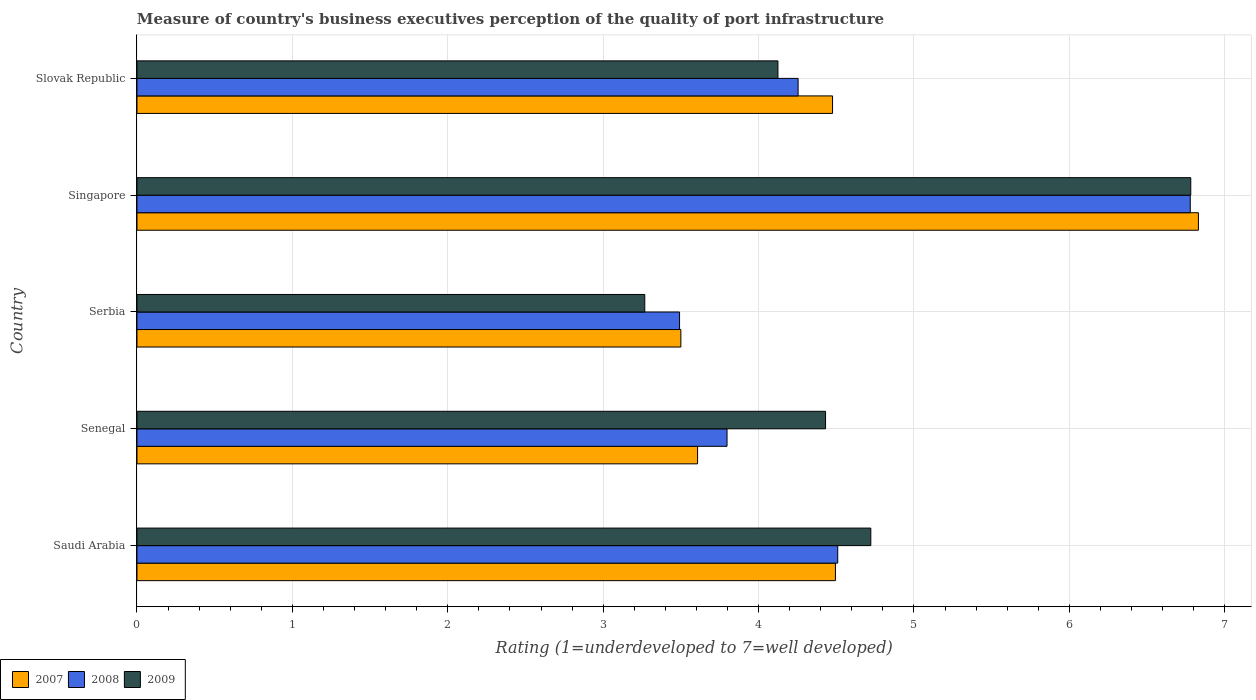How many different coloured bars are there?
Your response must be concise. 3. How many groups of bars are there?
Give a very brief answer. 5. How many bars are there on the 5th tick from the top?
Provide a succinct answer. 3. How many bars are there on the 3rd tick from the bottom?
Your answer should be compact. 3. What is the label of the 3rd group of bars from the top?
Offer a terse response. Serbia. What is the ratings of the quality of port infrastructure in 2007 in Slovak Republic?
Provide a short and direct response. 4.48. Across all countries, what is the maximum ratings of the quality of port infrastructure in 2007?
Your answer should be very brief. 6.83. Across all countries, what is the minimum ratings of the quality of port infrastructure in 2007?
Make the answer very short. 3.5. In which country was the ratings of the quality of port infrastructure in 2009 maximum?
Your response must be concise. Singapore. In which country was the ratings of the quality of port infrastructure in 2008 minimum?
Your response must be concise. Serbia. What is the total ratings of the quality of port infrastructure in 2008 in the graph?
Offer a very short reply. 22.83. What is the difference between the ratings of the quality of port infrastructure in 2007 in Senegal and that in Serbia?
Keep it short and to the point. 0.11. What is the difference between the ratings of the quality of port infrastructure in 2008 in Saudi Arabia and the ratings of the quality of port infrastructure in 2009 in Singapore?
Make the answer very short. -2.27. What is the average ratings of the quality of port infrastructure in 2007 per country?
Offer a terse response. 4.58. What is the difference between the ratings of the quality of port infrastructure in 2009 and ratings of the quality of port infrastructure in 2007 in Slovak Republic?
Provide a succinct answer. -0.35. What is the ratio of the ratings of the quality of port infrastructure in 2008 in Saudi Arabia to that in Serbia?
Provide a short and direct response. 1.29. Is the ratings of the quality of port infrastructure in 2009 in Serbia less than that in Slovak Republic?
Offer a very short reply. Yes. What is the difference between the highest and the second highest ratings of the quality of port infrastructure in 2007?
Your answer should be compact. 2.34. What is the difference between the highest and the lowest ratings of the quality of port infrastructure in 2007?
Make the answer very short. 3.33. In how many countries, is the ratings of the quality of port infrastructure in 2007 greater than the average ratings of the quality of port infrastructure in 2007 taken over all countries?
Keep it short and to the point. 1. Is the sum of the ratings of the quality of port infrastructure in 2007 in Senegal and Singapore greater than the maximum ratings of the quality of port infrastructure in 2008 across all countries?
Your answer should be very brief. Yes. What does the 1st bar from the top in Saudi Arabia represents?
Provide a short and direct response. 2009. How many bars are there?
Make the answer very short. 15. Are all the bars in the graph horizontal?
Provide a short and direct response. Yes. What is the difference between two consecutive major ticks on the X-axis?
Give a very brief answer. 1. Are the values on the major ticks of X-axis written in scientific E-notation?
Give a very brief answer. No. Does the graph contain grids?
Your answer should be very brief. Yes. Where does the legend appear in the graph?
Offer a terse response. Bottom left. How many legend labels are there?
Give a very brief answer. 3. How are the legend labels stacked?
Keep it short and to the point. Horizontal. What is the title of the graph?
Ensure brevity in your answer.  Measure of country's business executives perception of the quality of port infrastructure. Does "1981" appear as one of the legend labels in the graph?
Your response must be concise. No. What is the label or title of the X-axis?
Your answer should be very brief. Rating (1=underdeveloped to 7=well developed). What is the label or title of the Y-axis?
Your response must be concise. Country. What is the Rating (1=underdeveloped to 7=well developed) of 2007 in Saudi Arabia?
Keep it short and to the point. 4.49. What is the Rating (1=underdeveloped to 7=well developed) in 2008 in Saudi Arabia?
Provide a succinct answer. 4.51. What is the Rating (1=underdeveloped to 7=well developed) in 2009 in Saudi Arabia?
Provide a succinct answer. 4.72. What is the Rating (1=underdeveloped to 7=well developed) in 2007 in Senegal?
Offer a very short reply. 3.61. What is the Rating (1=underdeveloped to 7=well developed) of 2008 in Senegal?
Provide a succinct answer. 3.8. What is the Rating (1=underdeveloped to 7=well developed) in 2009 in Senegal?
Your answer should be compact. 4.43. What is the Rating (1=underdeveloped to 7=well developed) in 2007 in Serbia?
Keep it short and to the point. 3.5. What is the Rating (1=underdeveloped to 7=well developed) of 2008 in Serbia?
Offer a very short reply. 3.49. What is the Rating (1=underdeveloped to 7=well developed) of 2009 in Serbia?
Keep it short and to the point. 3.27. What is the Rating (1=underdeveloped to 7=well developed) in 2007 in Singapore?
Ensure brevity in your answer.  6.83. What is the Rating (1=underdeveloped to 7=well developed) in 2008 in Singapore?
Your response must be concise. 6.78. What is the Rating (1=underdeveloped to 7=well developed) in 2009 in Singapore?
Your answer should be compact. 6.78. What is the Rating (1=underdeveloped to 7=well developed) in 2007 in Slovak Republic?
Offer a very short reply. 4.48. What is the Rating (1=underdeveloped to 7=well developed) of 2008 in Slovak Republic?
Ensure brevity in your answer.  4.25. What is the Rating (1=underdeveloped to 7=well developed) in 2009 in Slovak Republic?
Keep it short and to the point. 4.12. Across all countries, what is the maximum Rating (1=underdeveloped to 7=well developed) of 2007?
Your response must be concise. 6.83. Across all countries, what is the maximum Rating (1=underdeveloped to 7=well developed) in 2008?
Your answer should be compact. 6.78. Across all countries, what is the maximum Rating (1=underdeveloped to 7=well developed) in 2009?
Provide a succinct answer. 6.78. Across all countries, what is the minimum Rating (1=underdeveloped to 7=well developed) of 2008?
Provide a succinct answer. 3.49. Across all countries, what is the minimum Rating (1=underdeveloped to 7=well developed) in 2009?
Provide a short and direct response. 3.27. What is the total Rating (1=underdeveloped to 7=well developed) in 2007 in the graph?
Make the answer very short. 22.91. What is the total Rating (1=underdeveloped to 7=well developed) in 2008 in the graph?
Your response must be concise. 22.83. What is the total Rating (1=underdeveloped to 7=well developed) in 2009 in the graph?
Keep it short and to the point. 23.33. What is the difference between the Rating (1=underdeveloped to 7=well developed) in 2007 in Saudi Arabia and that in Senegal?
Keep it short and to the point. 0.89. What is the difference between the Rating (1=underdeveloped to 7=well developed) in 2008 in Saudi Arabia and that in Senegal?
Make the answer very short. 0.71. What is the difference between the Rating (1=underdeveloped to 7=well developed) in 2009 in Saudi Arabia and that in Senegal?
Offer a very short reply. 0.29. What is the difference between the Rating (1=underdeveloped to 7=well developed) of 2008 in Saudi Arabia and that in Serbia?
Your answer should be compact. 1.02. What is the difference between the Rating (1=underdeveloped to 7=well developed) of 2009 in Saudi Arabia and that in Serbia?
Your response must be concise. 1.45. What is the difference between the Rating (1=underdeveloped to 7=well developed) in 2007 in Saudi Arabia and that in Singapore?
Offer a very short reply. -2.34. What is the difference between the Rating (1=underdeveloped to 7=well developed) of 2008 in Saudi Arabia and that in Singapore?
Give a very brief answer. -2.27. What is the difference between the Rating (1=underdeveloped to 7=well developed) of 2009 in Saudi Arabia and that in Singapore?
Provide a short and direct response. -2.06. What is the difference between the Rating (1=underdeveloped to 7=well developed) in 2007 in Saudi Arabia and that in Slovak Republic?
Provide a succinct answer. 0.02. What is the difference between the Rating (1=underdeveloped to 7=well developed) in 2008 in Saudi Arabia and that in Slovak Republic?
Offer a very short reply. 0.25. What is the difference between the Rating (1=underdeveloped to 7=well developed) in 2009 in Saudi Arabia and that in Slovak Republic?
Offer a very short reply. 0.6. What is the difference between the Rating (1=underdeveloped to 7=well developed) of 2007 in Senegal and that in Serbia?
Keep it short and to the point. 0.11. What is the difference between the Rating (1=underdeveloped to 7=well developed) in 2008 in Senegal and that in Serbia?
Keep it short and to the point. 0.31. What is the difference between the Rating (1=underdeveloped to 7=well developed) in 2009 in Senegal and that in Serbia?
Keep it short and to the point. 1.16. What is the difference between the Rating (1=underdeveloped to 7=well developed) of 2007 in Senegal and that in Singapore?
Your answer should be compact. -3.22. What is the difference between the Rating (1=underdeveloped to 7=well developed) of 2008 in Senegal and that in Singapore?
Ensure brevity in your answer.  -2.98. What is the difference between the Rating (1=underdeveloped to 7=well developed) of 2009 in Senegal and that in Singapore?
Provide a succinct answer. -2.35. What is the difference between the Rating (1=underdeveloped to 7=well developed) in 2007 in Senegal and that in Slovak Republic?
Provide a short and direct response. -0.87. What is the difference between the Rating (1=underdeveloped to 7=well developed) of 2008 in Senegal and that in Slovak Republic?
Your response must be concise. -0.46. What is the difference between the Rating (1=underdeveloped to 7=well developed) of 2009 in Senegal and that in Slovak Republic?
Your answer should be very brief. 0.31. What is the difference between the Rating (1=underdeveloped to 7=well developed) in 2007 in Serbia and that in Singapore?
Give a very brief answer. -3.33. What is the difference between the Rating (1=underdeveloped to 7=well developed) in 2008 in Serbia and that in Singapore?
Give a very brief answer. -3.29. What is the difference between the Rating (1=underdeveloped to 7=well developed) of 2009 in Serbia and that in Singapore?
Make the answer very short. -3.51. What is the difference between the Rating (1=underdeveloped to 7=well developed) in 2007 in Serbia and that in Slovak Republic?
Make the answer very short. -0.98. What is the difference between the Rating (1=underdeveloped to 7=well developed) of 2008 in Serbia and that in Slovak Republic?
Your answer should be compact. -0.76. What is the difference between the Rating (1=underdeveloped to 7=well developed) of 2009 in Serbia and that in Slovak Republic?
Provide a succinct answer. -0.86. What is the difference between the Rating (1=underdeveloped to 7=well developed) in 2007 in Singapore and that in Slovak Republic?
Your response must be concise. 2.35. What is the difference between the Rating (1=underdeveloped to 7=well developed) in 2008 in Singapore and that in Slovak Republic?
Keep it short and to the point. 2.52. What is the difference between the Rating (1=underdeveloped to 7=well developed) of 2009 in Singapore and that in Slovak Republic?
Give a very brief answer. 2.66. What is the difference between the Rating (1=underdeveloped to 7=well developed) of 2007 in Saudi Arabia and the Rating (1=underdeveloped to 7=well developed) of 2008 in Senegal?
Make the answer very short. 0.7. What is the difference between the Rating (1=underdeveloped to 7=well developed) in 2007 in Saudi Arabia and the Rating (1=underdeveloped to 7=well developed) in 2009 in Senegal?
Your answer should be compact. 0.06. What is the difference between the Rating (1=underdeveloped to 7=well developed) in 2008 in Saudi Arabia and the Rating (1=underdeveloped to 7=well developed) in 2009 in Senegal?
Offer a very short reply. 0.08. What is the difference between the Rating (1=underdeveloped to 7=well developed) of 2007 in Saudi Arabia and the Rating (1=underdeveloped to 7=well developed) of 2008 in Serbia?
Provide a short and direct response. 1. What is the difference between the Rating (1=underdeveloped to 7=well developed) of 2007 in Saudi Arabia and the Rating (1=underdeveloped to 7=well developed) of 2009 in Serbia?
Offer a very short reply. 1.23. What is the difference between the Rating (1=underdeveloped to 7=well developed) in 2008 in Saudi Arabia and the Rating (1=underdeveloped to 7=well developed) in 2009 in Serbia?
Your answer should be compact. 1.24. What is the difference between the Rating (1=underdeveloped to 7=well developed) in 2007 in Saudi Arabia and the Rating (1=underdeveloped to 7=well developed) in 2008 in Singapore?
Your answer should be very brief. -2.28. What is the difference between the Rating (1=underdeveloped to 7=well developed) of 2007 in Saudi Arabia and the Rating (1=underdeveloped to 7=well developed) of 2009 in Singapore?
Ensure brevity in your answer.  -2.29. What is the difference between the Rating (1=underdeveloped to 7=well developed) of 2008 in Saudi Arabia and the Rating (1=underdeveloped to 7=well developed) of 2009 in Singapore?
Give a very brief answer. -2.27. What is the difference between the Rating (1=underdeveloped to 7=well developed) in 2007 in Saudi Arabia and the Rating (1=underdeveloped to 7=well developed) in 2008 in Slovak Republic?
Provide a short and direct response. 0.24. What is the difference between the Rating (1=underdeveloped to 7=well developed) of 2007 in Saudi Arabia and the Rating (1=underdeveloped to 7=well developed) of 2009 in Slovak Republic?
Offer a terse response. 0.37. What is the difference between the Rating (1=underdeveloped to 7=well developed) of 2008 in Saudi Arabia and the Rating (1=underdeveloped to 7=well developed) of 2009 in Slovak Republic?
Provide a short and direct response. 0.38. What is the difference between the Rating (1=underdeveloped to 7=well developed) of 2007 in Senegal and the Rating (1=underdeveloped to 7=well developed) of 2008 in Serbia?
Your answer should be very brief. 0.12. What is the difference between the Rating (1=underdeveloped to 7=well developed) in 2007 in Senegal and the Rating (1=underdeveloped to 7=well developed) in 2009 in Serbia?
Your answer should be compact. 0.34. What is the difference between the Rating (1=underdeveloped to 7=well developed) in 2008 in Senegal and the Rating (1=underdeveloped to 7=well developed) in 2009 in Serbia?
Offer a terse response. 0.53. What is the difference between the Rating (1=underdeveloped to 7=well developed) in 2007 in Senegal and the Rating (1=underdeveloped to 7=well developed) in 2008 in Singapore?
Make the answer very short. -3.17. What is the difference between the Rating (1=underdeveloped to 7=well developed) of 2007 in Senegal and the Rating (1=underdeveloped to 7=well developed) of 2009 in Singapore?
Your answer should be compact. -3.17. What is the difference between the Rating (1=underdeveloped to 7=well developed) in 2008 in Senegal and the Rating (1=underdeveloped to 7=well developed) in 2009 in Singapore?
Ensure brevity in your answer.  -2.98. What is the difference between the Rating (1=underdeveloped to 7=well developed) in 2007 in Senegal and the Rating (1=underdeveloped to 7=well developed) in 2008 in Slovak Republic?
Offer a terse response. -0.65. What is the difference between the Rating (1=underdeveloped to 7=well developed) in 2007 in Senegal and the Rating (1=underdeveloped to 7=well developed) in 2009 in Slovak Republic?
Ensure brevity in your answer.  -0.52. What is the difference between the Rating (1=underdeveloped to 7=well developed) in 2008 in Senegal and the Rating (1=underdeveloped to 7=well developed) in 2009 in Slovak Republic?
Provide a succinct answer. -0.33. What is the difference between the Rating (1=underdeveloped to 7=well developed) of 2007 in Serbia and the Rating (1=underdeveloped to 7=well developed) of 2008 in Singapore?
Give a very brief answer. -3.28. What is the difference between the Rating (1=underdeveloped to 7=well developed) in 2007 in Serbia and the Rating (1=underdeveloped to 7=well developed) in 2009 in Singapore?
Your answer should be very brief. -3.28. What is the difference between the Rating (1=underdeveloped to 7=well developed) of 2008 in Serbia and the Rating (1=underdeveloped to 7=well developed) of 2009 in Singapore?
Give a very brief answer. -3.29. What is the difference between the Rating (1=underdeveloped to 7=well developed) in 2007 in Serbia and the Rating (1=underdeveloped to 7=well developed) in 2008 in Slovak Republic?
Keep it short and to the point. -0.75. What is the difference between the Rating (1=underdeveloped to 7=well developed) in 2007 in Serbia and the Rating (1=underdeveloped to 7=well developed) in 2009 in Slovak Republic?
Your response must be concise. -0.62. What is the difference between the Rating (1=underdeveloped to 7=well developed) in 2008 in Serbia and the Rating (1=underdeveloped to 7=well developed) in 2009 in Slovak Republic?
Make the answer very short. -0.63. What is the difference between the Rating (1=underdeveloped to 7=well developed) in 2007 in Singapore and the Rating (1=underdeveloped to 7=well developed) in 2008 in Slovak Republic?
Offer a very short reply. 2.58. What is the difference between the Rating (1=underdeveloped to 7=well developed) of 2007 in Singapore and the Rating (1=underdeveloped to 7=well developed) of 2009 in Slovak Republic?
Your response must be concise. 2.71. What is the difference between the Rating (1=underdeveloped to 7=well developed) in 2008 in Singapore and the Rating (1=underdeveloped to 7=well developed) in 2009 in Slovak Republic?
Offer a very short reply. 2.65. What is the average Rating (1=underdeveloped to 7=well developed) in 2007 per country?
Your answer should be very brief. 4.58. What is the average Rating (1=underdeveloped to 7=well developed) of 2008 per country?
Offer a terse response. 4.57. What is the average Rating (1=underdeveloped to 7=well developed) of 2009 per country?
Ensure brevity in your answer.  4.67. What is the difference between the Rating (1=underdeveloped to 7=well developed) of 2007 and Rating (1=underdeveloped to 7=well developed) of 2008 in Saudi Arabia?
Offer a terse response. -0.01. What is the difference between the Rating (1=underdeveloped to 7=well developed) of 2007 and Rating (1=underdeveloped to 7=well developed) of 2009 in Saudi Arabia?
Offer a terse response. -0.23. What is the difference between the Rating (1=underdeveloped to 7=well developed) in 2008 and Rating (1=underdeveloped to 7=well developed) in 2009 in Saudi Arabia?
Give a very brief answer. -0.21. What is the difference between the Rating (1=underdeveloped to 7=well developed) in 2007 and Rating (1=underdeveloped to 7=well developed) in 2008 in Senegal?
Provide a succinct answer. -0.19. What is the difference between the Rating (1=underdeveloped to 7=well developed) in 2007 and Rating (1=underdeveloped to 7=well developed) in 2009 in Senegal?
Keep it short and to the point. -0.82. What is the difference between the Rating (1=underdeveloped to 7=well developed) in 2008 and Rating (1=underdeveloped to 7=well developed) in 2009 in Senegal?
Make the answer very short. -0.63. What is the difference between the Rating (1=underdeveloped to 7=well developed) in 2007 and Rating (1=underdeveloped to 7=well developed) in 2008 in Serbia?
Keep it short and to the point. 0.01. What is the difference between the Rating (1=underdeveloped to 7=well developed) of 2007 and Rating (1=underdeveloped to 7=well developed) of 2009 in Serbia?
Keep it short and to the point. 0.23. What is the difference between the Rating (1=underdeveloped to 7=well developed) of 2008 and Rating (1=underdeveloped to 7=well developed) of 2009 in Serbia?
Offer a terse response. 0.22. What is the difference between the Rating (1=underdeveloped to 7=well developed) of 2007 and Rating (1=underdeveloped to 7=well developed) of 2008 in Singapore?
Keep it short and to the point. 0.05. What is the difference between the Rating (1=underdeveloped to 7=well developed) of 2007 and Rating (1=underdeveloped to 7=well developed) of 2009 in Singapore?
Your answer should be compact. 0.05. What is the difference between the Rating (1=underdeveloped to 7=well developed) in 2008 and Rating (1=underdeveloped to 7=well developed) in 2009 in Singapore?
Give a very brief answer. -0. What is the difference between the Rating (1=underdeveloped to 7=well developed) of 2007 and Rating (1=underdeveloped to 7=well developed) of 2008 in Slovak Republic?
Give a very brief answer. 0.22. What is the difference between the Rating (1=underdeveloped to 7=well developed) in 2007 and Rating (1=underdeveloped to 7=well developed) in 2009 in Slovak Republic?
Offer a very short reply. 0.35. What is the difference between the Rating (1=underdeveloped to 7=well developed) of 2008 and Rating (1=underdeveloped to 7=well developed) of 2009 in Slovak Republic?
Your answer should be very brief. 0.13. What is the ratio of the Rating (1=underdeveloped to 7=well developed) in 2007 in Saudi Arabia to that in Senegal?
Keep it short and to the point. 1.25. What is the ratio of the Rating (1=underdeveloped to 7=well developed) in 2008 in Saudi Arabia to that in Senegal?
Make the answer very short. 1.19. What is the ratio of the Rating (1=underdeveloped to 7=well developed) of 2009 in Saudi Arabia to that in Senegal?
Your answer should be very brief. 1.07. What is the ratio of the Rating (1=underdeveloped to 7=well developed) in 2007 in Saudi Arabia to that in Serbia?
Offer a terse response. 1.28. What is the ratio of the Rating (1=underdeveloped to 7=well developed) in 2008 in Saudi Arabia to that in Serbia?
Your answer should be very brief. 1.29. What is the ratio of the Rating (1=underdeveloped to 7=well developed) of 2009 in Saudi Arabia to that in Serbia?
Provide a succinct answer. 1.45. What is the ratio of the Rating (1=underdeveloped to 7=well developed) of 2007 in Saudi Arabia to that in Singapore?
Your answer should be compact. 0.66. What is the ratio of the Rating (1=underdeveloped to 7=well developed) of 2008 in Saudi Arabia to that in Singapore?
Your response must be concise. 0.67. What is the ratio of the Rating (1=underdeveloped to 7=well developed) in 2009 in Saudi Arabia to that in Singapore?
Provide a succinct answer. 0.7. What is the ratio of the Rating (1=underdeveloped to 7=well developed) of 2007 in Saudi Arabia to that in Slovak Republic?
Give a very brief answer. 1. What is the ratio of the Rating (1=underdeveloped to 7=well developed) of 2008 in Saudi Arabia to that in Slovak Republic?
Your answer should be very brief. 1.06. What is the ratio of the Rating (1=underdeveloped to 7=well developed) of 2009 in Saudi Arabia to that in Slovak Republic?
Make the answer very short. 1.14. What is the ratio of the Rating (1=underdeveloped to 7=well developed) of 2007 in Senegal to that in Serbia?
Your response must be concise. 1.03. What is the ratio of the Rating (1=underdeveloped to 7=well developed) in 2008 in Senegal to that in Serbia?
Make the answer very short. 1.09. What is the ratio of the Rating (1=underdeveloped to 7=well developed) in 2009 in Senegal to that in Serbia?
Provide a short and direct response. 1.36. What is the ratio of the Rating (1=underdeveloped to 7=well developed) in 2007 in Senegal to that in Singapore?
Give a very brief answer. 0.53. What is the ratio of the Rating (1=underdeveloped to 7=well developed) in 2008 in Senegal to that in Singapore?
Keep it short and to the point. 0.56. What is the ratio of the Rating (1=underdeveloped to 7=well developed) in 2009 in Senegal to that in Singapore?
Give a very brief answer. 0.65. What is the ratio of the Rating (1=underdeveloped to 7=well developed) in 2007 in Senegal to that in Slovak Republic?
Your answer should be very brief. 0.81. What is the ratio of the Rating (1=underdeveloped to 7=well developed) of 2008 in Senegal to that in Slovak Republic?
Your response must be concise. 0.89. What is the ratio of the Rating (1=underdeveloped to 7=well developed) in 2009 in Senegal to that in Slovak Republic?
Ensure brevity in your answer.  1.07. What is the ratio of the Rating (1=underdeveloped to 7=well developed) in 2007 in Serbia to that in Singapore?
Keep it short and to the point. 0.51. What is the ratio of the Rating (1=underdeveloped to 7=well developed) of 2008 in Serbia to that in Singapore?
Keep it short and to the point. 0.52. What is the ratio of the Rating (1=underdeveloped to 7=well developed) in 2009 in Serbia to that in Singapore?
Offer a terse response. 0.48. What is the ratio of the Rating (1=underdeveloped to 7=well developed) in 2007 in Serbia to that in Slovak Republic?
Your answer should be very brief. 0.78. What is the ratio of the Rating (1=underdeveloped to 7=well developed) of 2008 in Serbia to that in Slovak Republic?
Make the answer very short. 0.82. What is the ratio of the Rating (1=underdeveloped to 7=well developed) of 2009 in Serbia to that in Slovak Republic?
Offer a terse response. 0.79. What is the ratio of the Rating (1=underdeveloped to 7=well developed) of 2007 in Singapore to that in Slovak Republic?
Your response must be concise. 1.53. What is the ratio of the Rating (1=underdeveloped to 7=well developed) of 2008 in Singapore to that in Slovak Republic?
Your answer should be very brief. 1.59. What is the ratio of the Rating (1=underdeveloped to 7=well developed) in 2009 in Singapore to that in Slovak Republic?
Keep it short and to the point. 1.64. What is the difference between the highest and the second highest Rating (1=underdeveloped to 7=well developed) in 2007?
Offer a very short reply. 2.34. What is the difference between the highest and the second highest Rating (1=underdeveloped to 7=well developed) of 2008?
Your response must be concise. 2.27. What is the difference between the highest and the second highest Rating (1=underdeveloped to 7=well developed) in 2009?
Make the answer very short. 2.06. What is the difference between the highest and the lowest Rating (1=underdeveloped to 7=well developed) of 2007?
Provide a short and direct response. 3.33. What is the difference between the highest and the lowest Rating (1=underdeveloped to 7=well developed) in 2008?
Ensure brevity in your answer.  3.29. What is the difference between the highest and the lowest Rating (1=underdeveloped to 7=well developed) in 2009?
Make the answer very short. 3.51. 